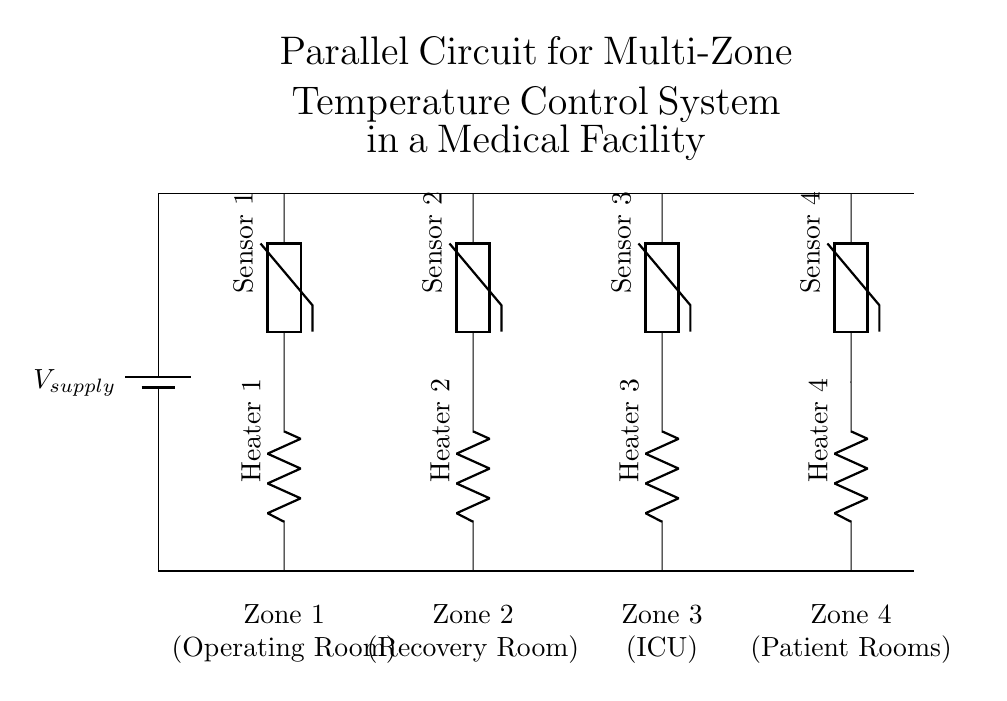What is the total number of zones in this circuit? The circuit diagram shows four distinct zones (Operating Room, Recovery Room, ICU, Patient Rooms), each represented by a separate branch.
Answer: Four What components are used in Zone 1? Zone 1 consists of two components: Heater 1 and Sensor 1, connected in series. The heater provides warmth while the sensor monitors the temperature.
Answer: Heater 1 and Sensor 1 What is the function of the thermistors in this circuit? The thermistors in this circuit act as temperature sensors for each zone, allowing for temperature monitoring to control the heaters effectively.
Answer: Temperature sensors What happens to the heaters if one zone's sensor fails? Since the circuit is parallel, if one zone's sensor fails, it will not affect the operation of the other zones, allowing them to continue functioning normally.
Answer: Other zones continue functioning How are the heaters powered in this circuit? All heaters are connected in parallel; hence, they receive the same voltage from the power supply, which allows for individual control of each zone's temperature.
Answer: Receive the same voltage Which zone is designated for the ICU? Zone 3 is specifically designated for the ICU, as indicated by its label in the diagram.
Answer: Zone 3 